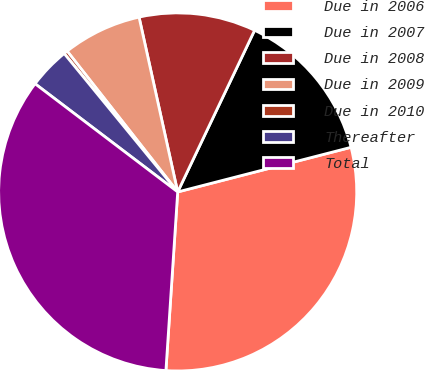<chart> <loc_0><loc_0><loc_500><loc_500><pie_chart><fcel>Due in 2006<fcel>Due in 2007<fcel>Due in 2008<fcel>Due in 2009<fcel>Due in 2010<fcel>Thereafter<fcel>Total<nl><fcel>30.06%<fcel>13.92%<fcel>10.53%<fcel>7.13%<fcel>0.34%<fcel>3.74%<fcel>34.28%<nl></chart> 